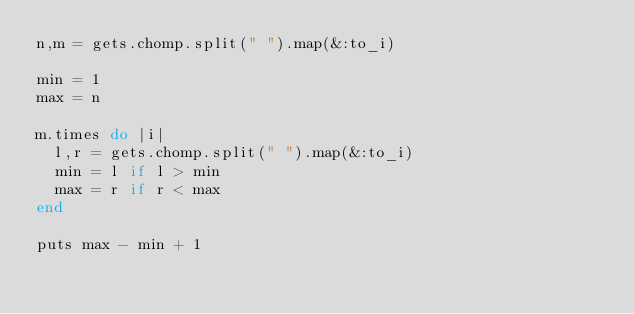<code> <loc_0><loc_0><loc_500><loc_500><_Ruby_>n,m = gets.chomp.split(" ").map(&:to_i)

min = 1
max = n

m.times do |i|
  l,r = gets.chomp.split(" ").map(&:to_i)
  min = l if l > min
  max = r if r < max
end

puts max - min + 1

</code> 